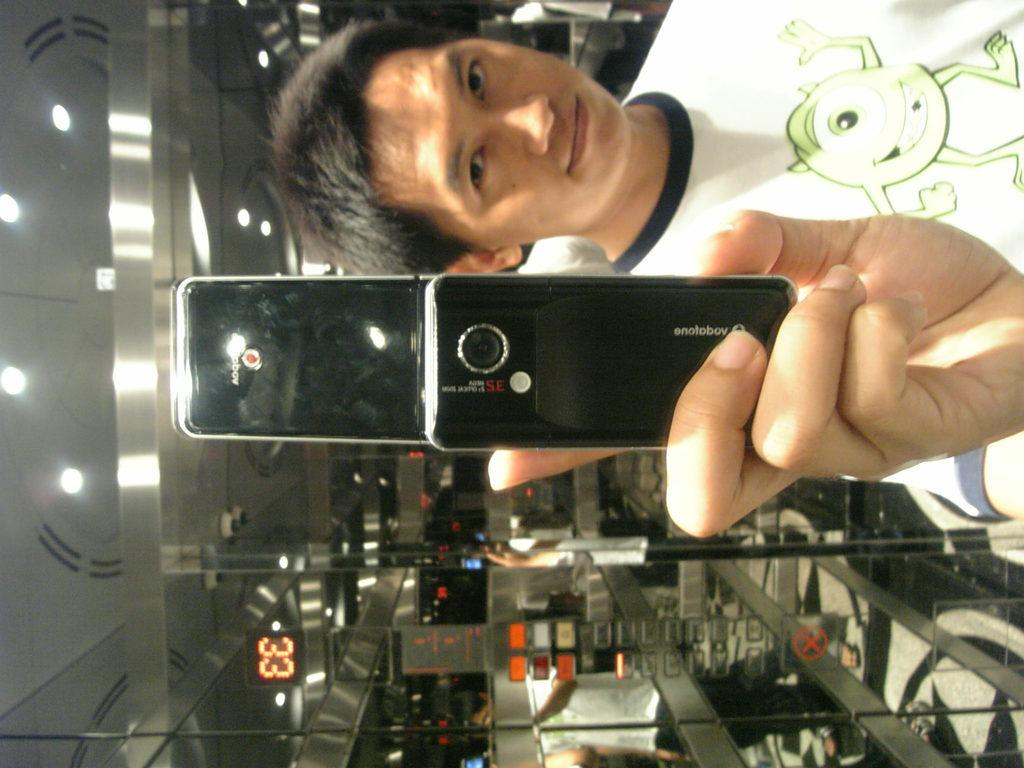Who is present in the image? There is a man in the image. What is the man holding in the image? The man is holding a mobile phone. What can be seen in the background of the image? There is a clock number and lights visible in the background of the image. What type of yak can be seen in the image? There is no yak present in the image. What is the relation between the man and the person on the other end of the phone call? The image does not provide information about the man's relationship with the person on the other end of the phone call. 